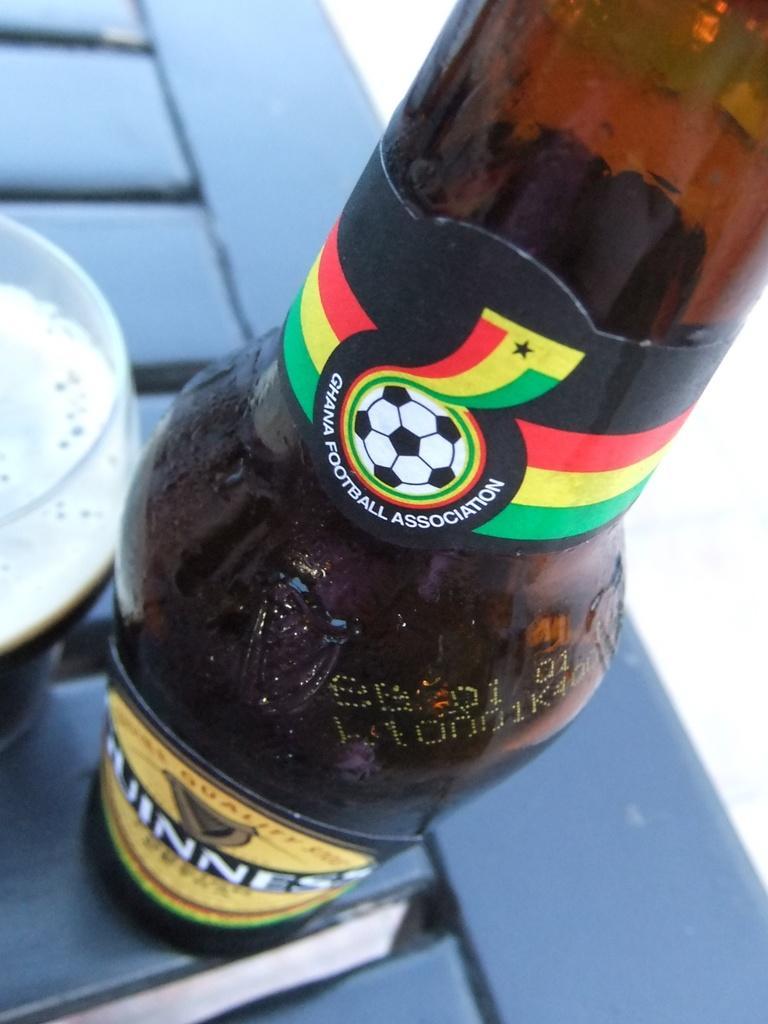Could you give a brief overview of what you see in this image? In this picture we can see a bottle and a glass on the table. 